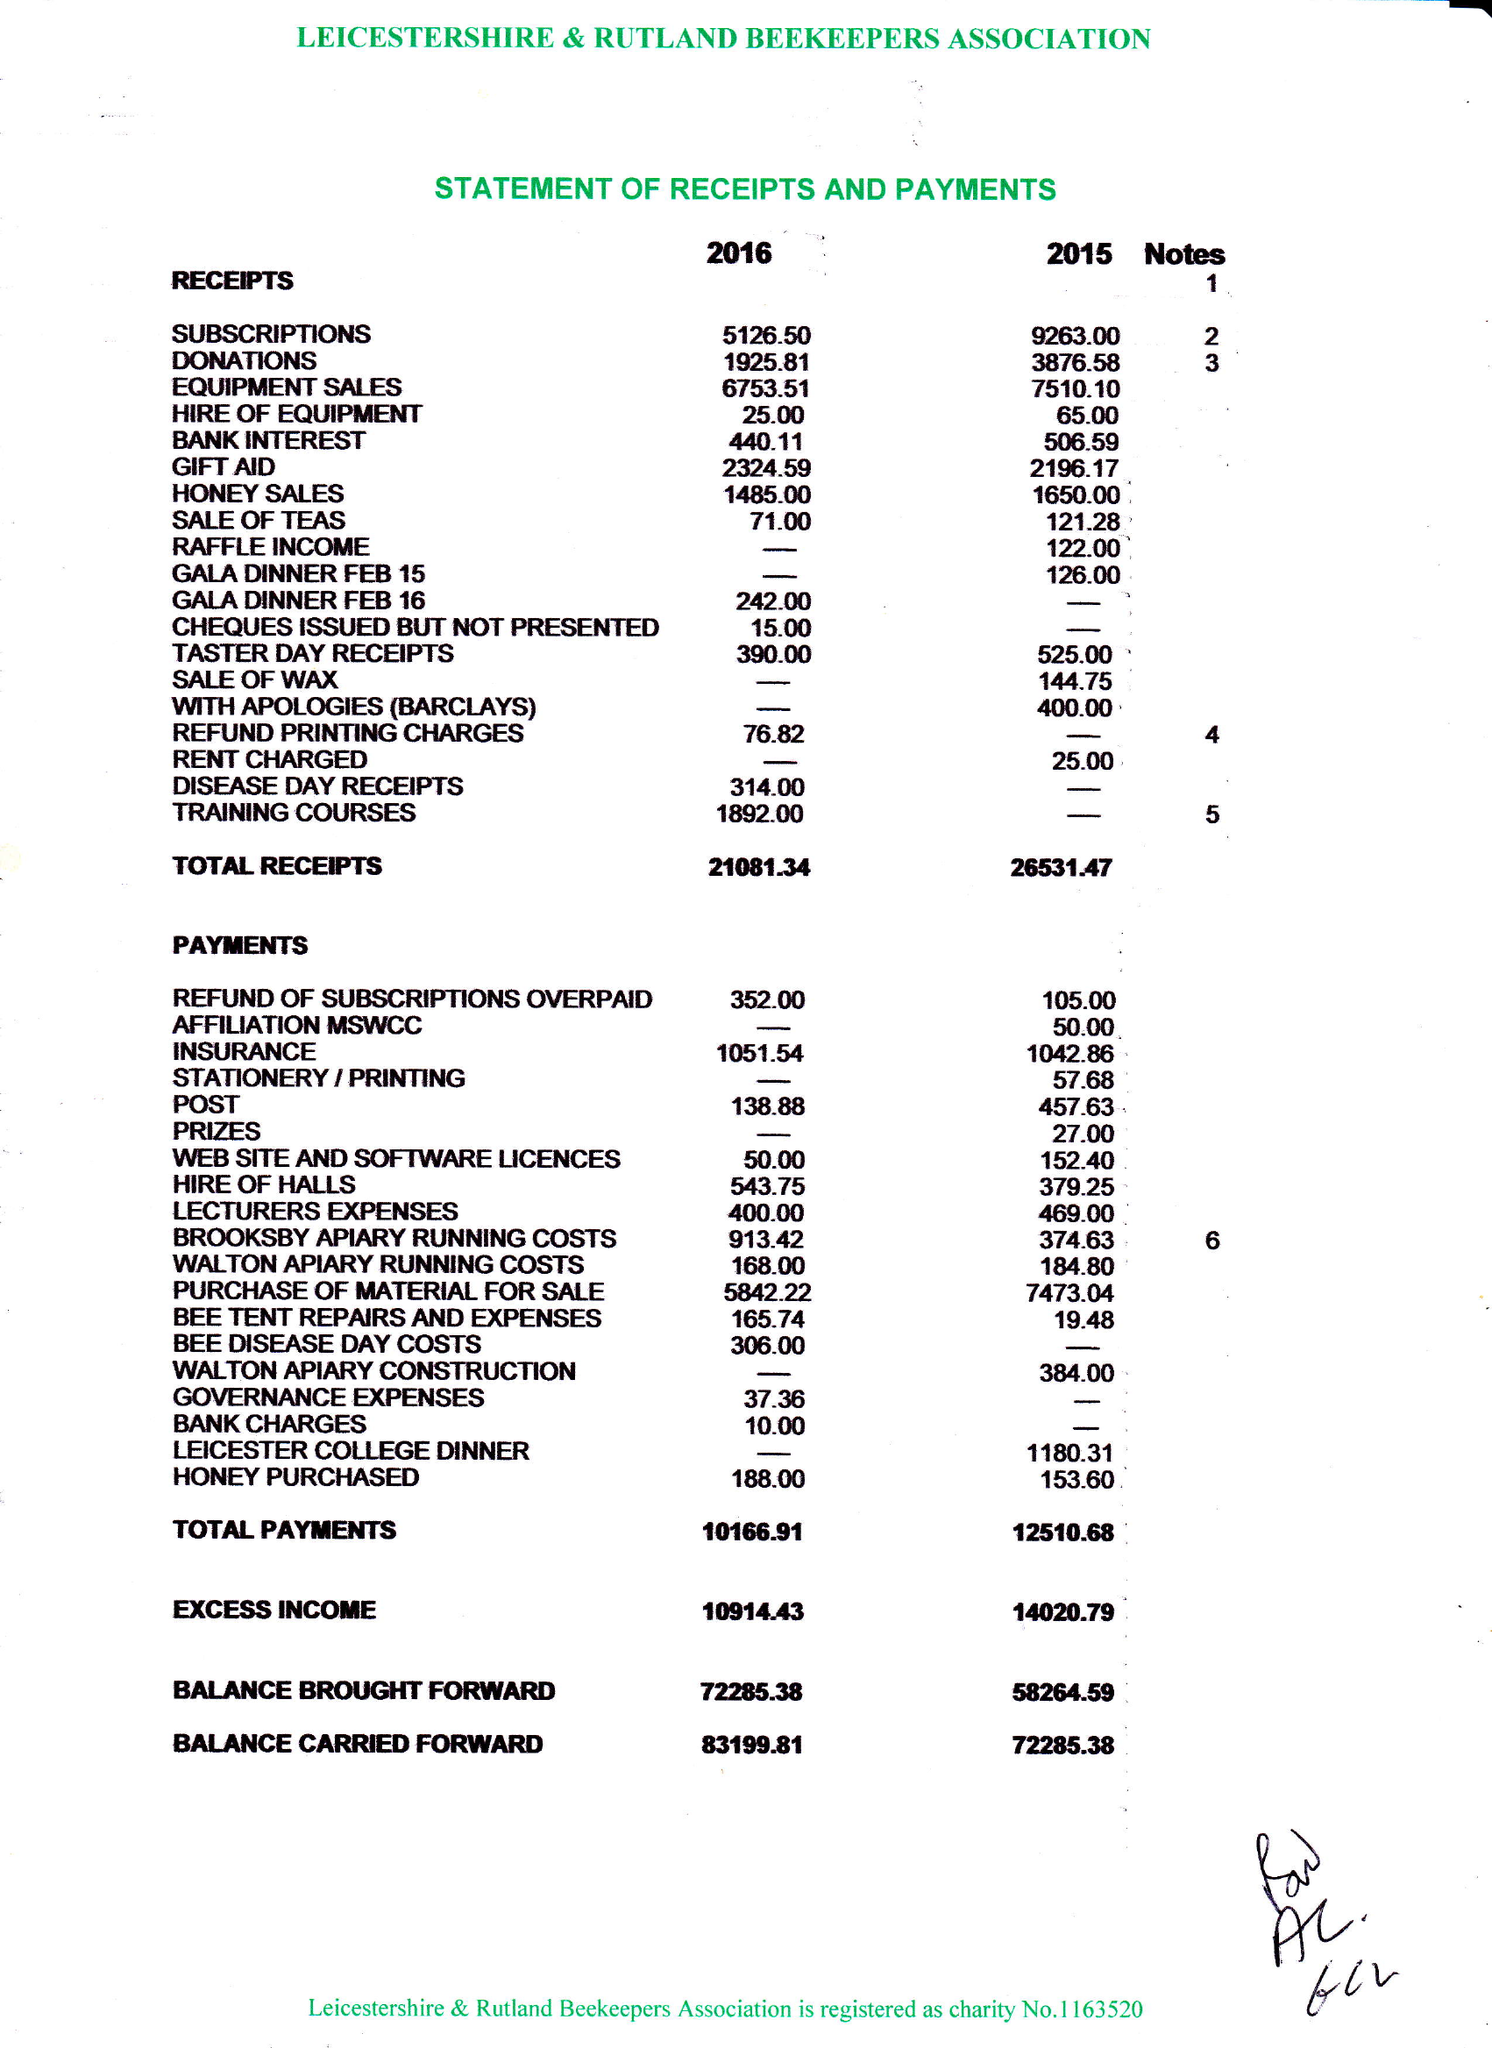What is the value for the report_date?
Answer the question using a single word or phrase. 2016-12-31 